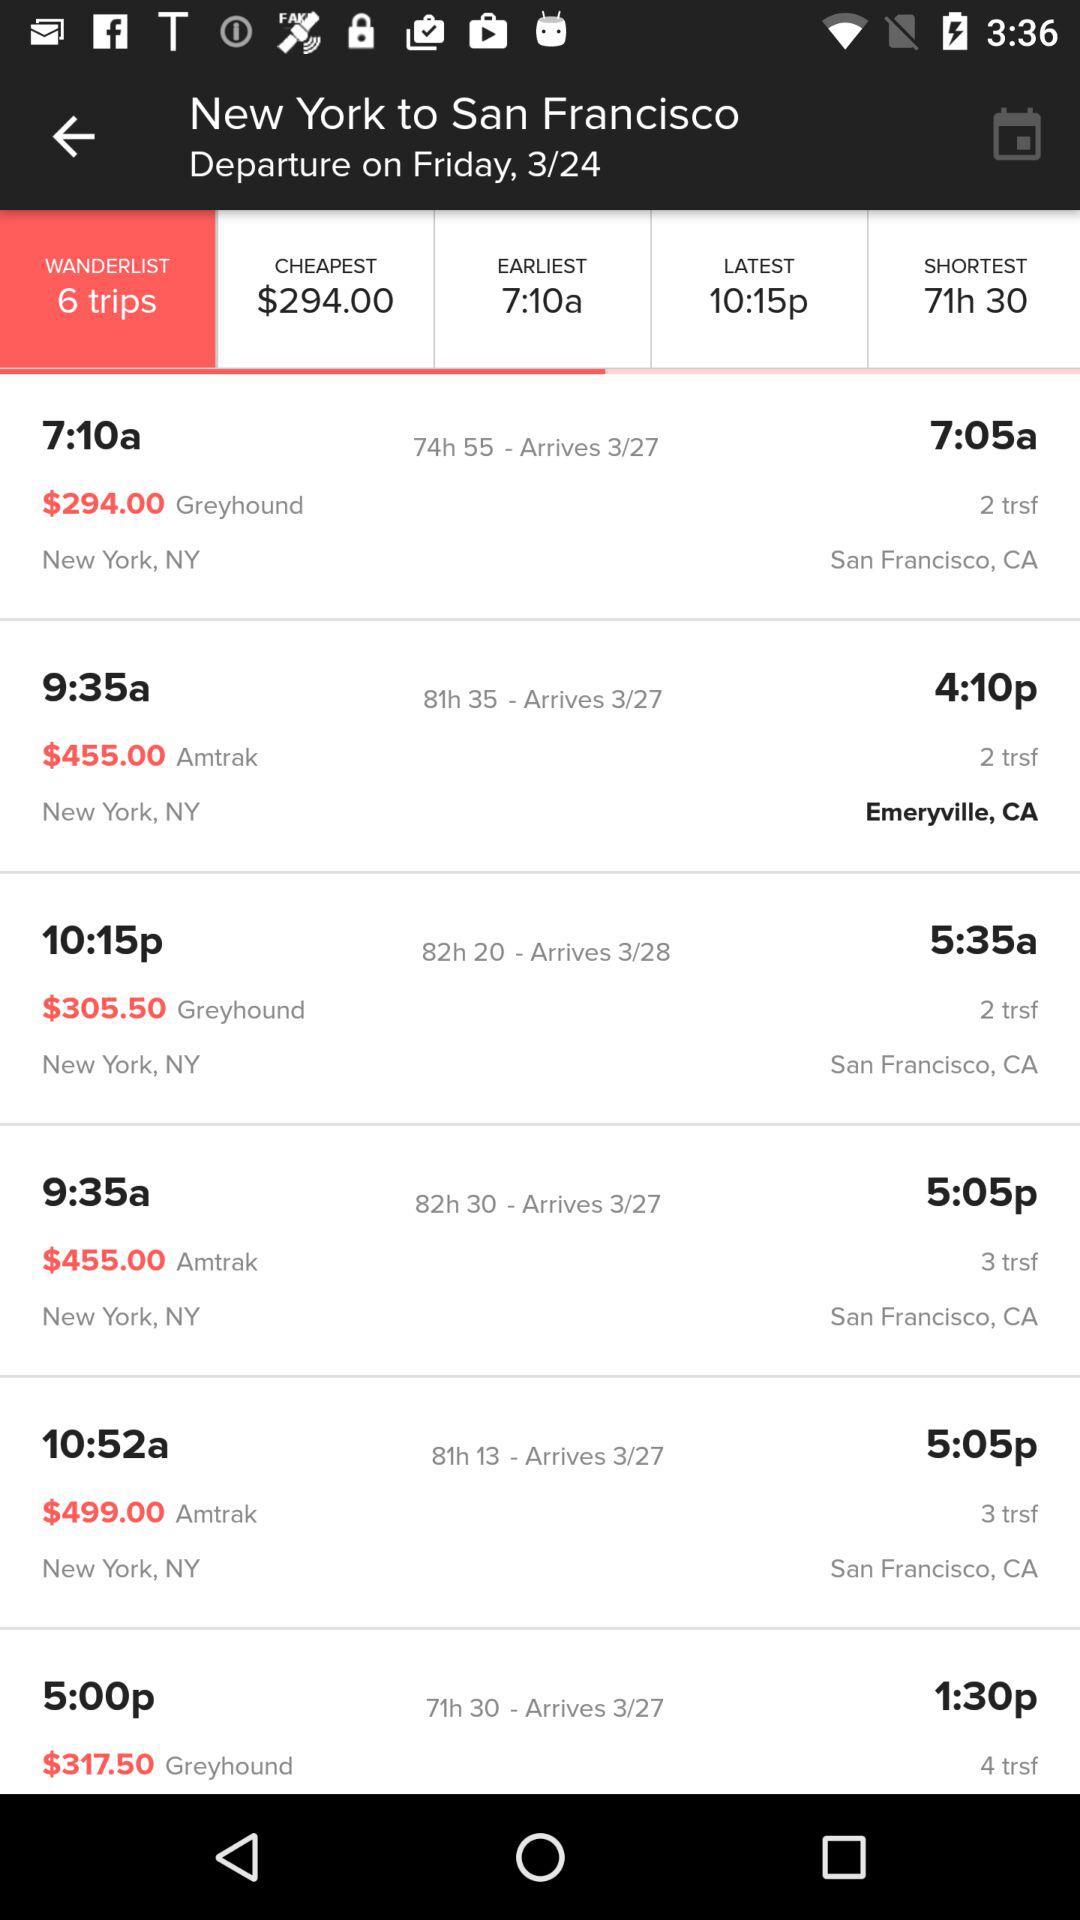How many trips are available?
Answer the question using a single word or phrase. 6 